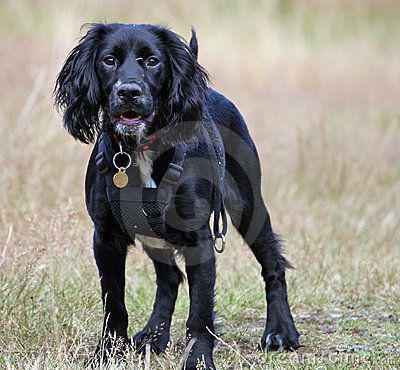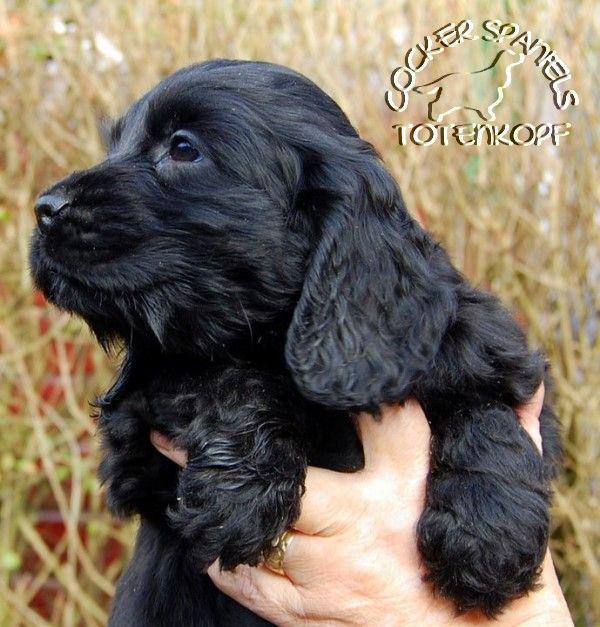The first image is the image on the left, the second image is the image on the right. For the images displayed, is the sentence "The dog in the image on the right is being held up outside." factually correct? Answer yes or no. Yes. The first image is the image on the left, the second image is the image on the right. Given the left and right images, does the statement "There are two dogs with black fur and floppy ears." hold true? Answer yes or no. Yes. 